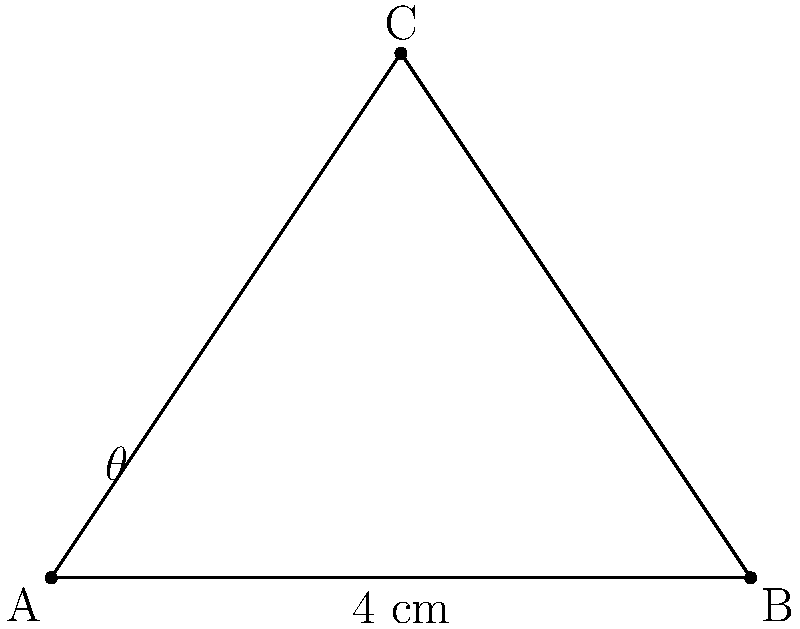In a prosthetic knee joint design, point A represents the top of the thigh component, point B the bottom of the shin component, and point C the pivot point. Given the coordinates A(0,0), B(4,0), and C(2,3) in centimeters, calculate the angle $\theta$ (in degrees) at which the knee joint is flexed. To find the angle $\theta$, we can use the law of cosines:

1) First, calculate the lengths of all sides:
   AB = 4 cm (given)
   AC = $\sqrt{(2-0)^2 + (3-0)^2} = \sqrt{4 + 9} = \sqrt{13}$ cm
   BC = $\sqrt{(2-4)^2 + (3-0)^2} = \sqrt{4 + 9} = \sqrt{13}$ cm

2) Apply the law of cosines:
   $\cos(\theta) = \frac{AC^2 + BC^2 - AB^2}{2(AC)(BC)}$

3) Substitute the values:
   $\cos(\theta) = \frac{(\sqrt{13})^2 + (\sqrt{13})^2 - 4^2}{2(\sqrt{13})(\sqrt{13})}$

4) Simplify:
   $\cos(\theta) = \frac{13 + 13 - 16}{26} = \frac{10}{26} = \frac{5}{13}$

5) Take the inverse cosine (arccos) of both sides:
   $\theta = \arccos(\frac{5}{13})$

6) Calculate the result:
   $\theta \approx 67.38$ degrees

Therefore, the knee joint is flexed at an angle of approximately 67.38 degrees.
Answer: $67.38^\circ$ 